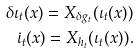Convert formula to latex. <formula><loc_0><loc_0><loc_500><loc_500>\delta \iota _ { t } ( x ) = X _ { \delta g _ { t } } ( \iota _ { t } ( x ) ) \\ \dot { \iota } _ { t } ( x ) = X _ { h _ { t } } ( \iota _ { t } ( x ) ) .</formula> 